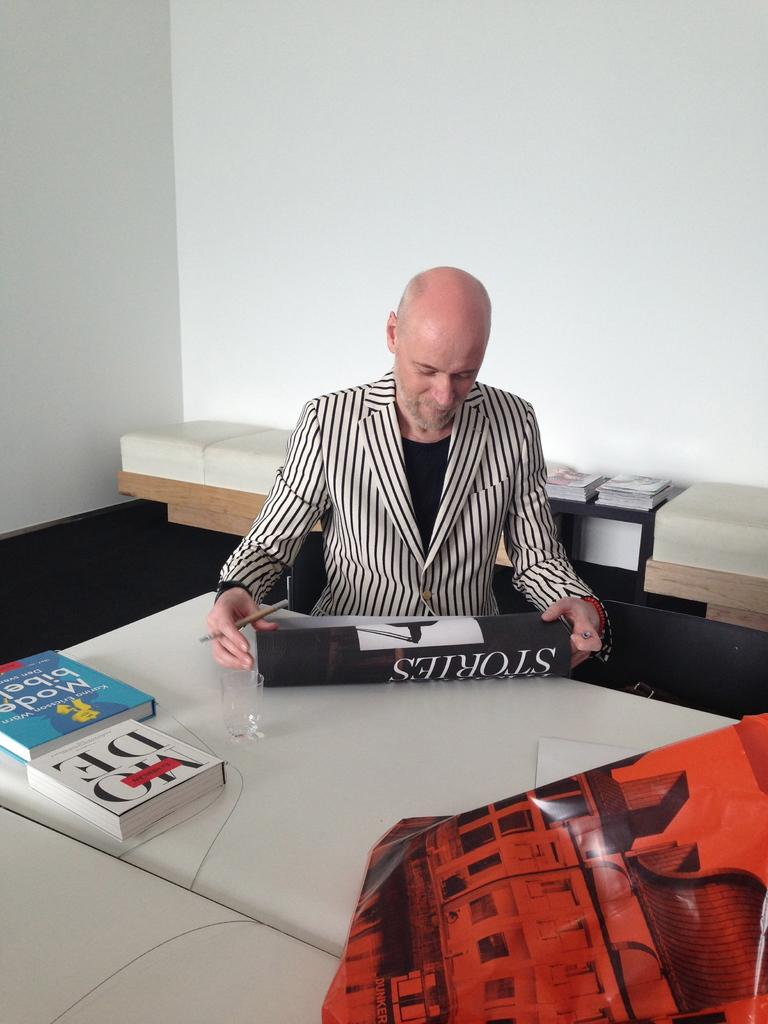What is the color of the wall in the image? The wall in the image is white. What piece of furniture is present in the image? There is a table in the image. What is the man in the image doing? The man is sitting on the table. What else is on the table besides the man? There is a bag and books on the table. What type of bean is being roasted on the table in the image? There is no bean or roasting activity present in the image. 